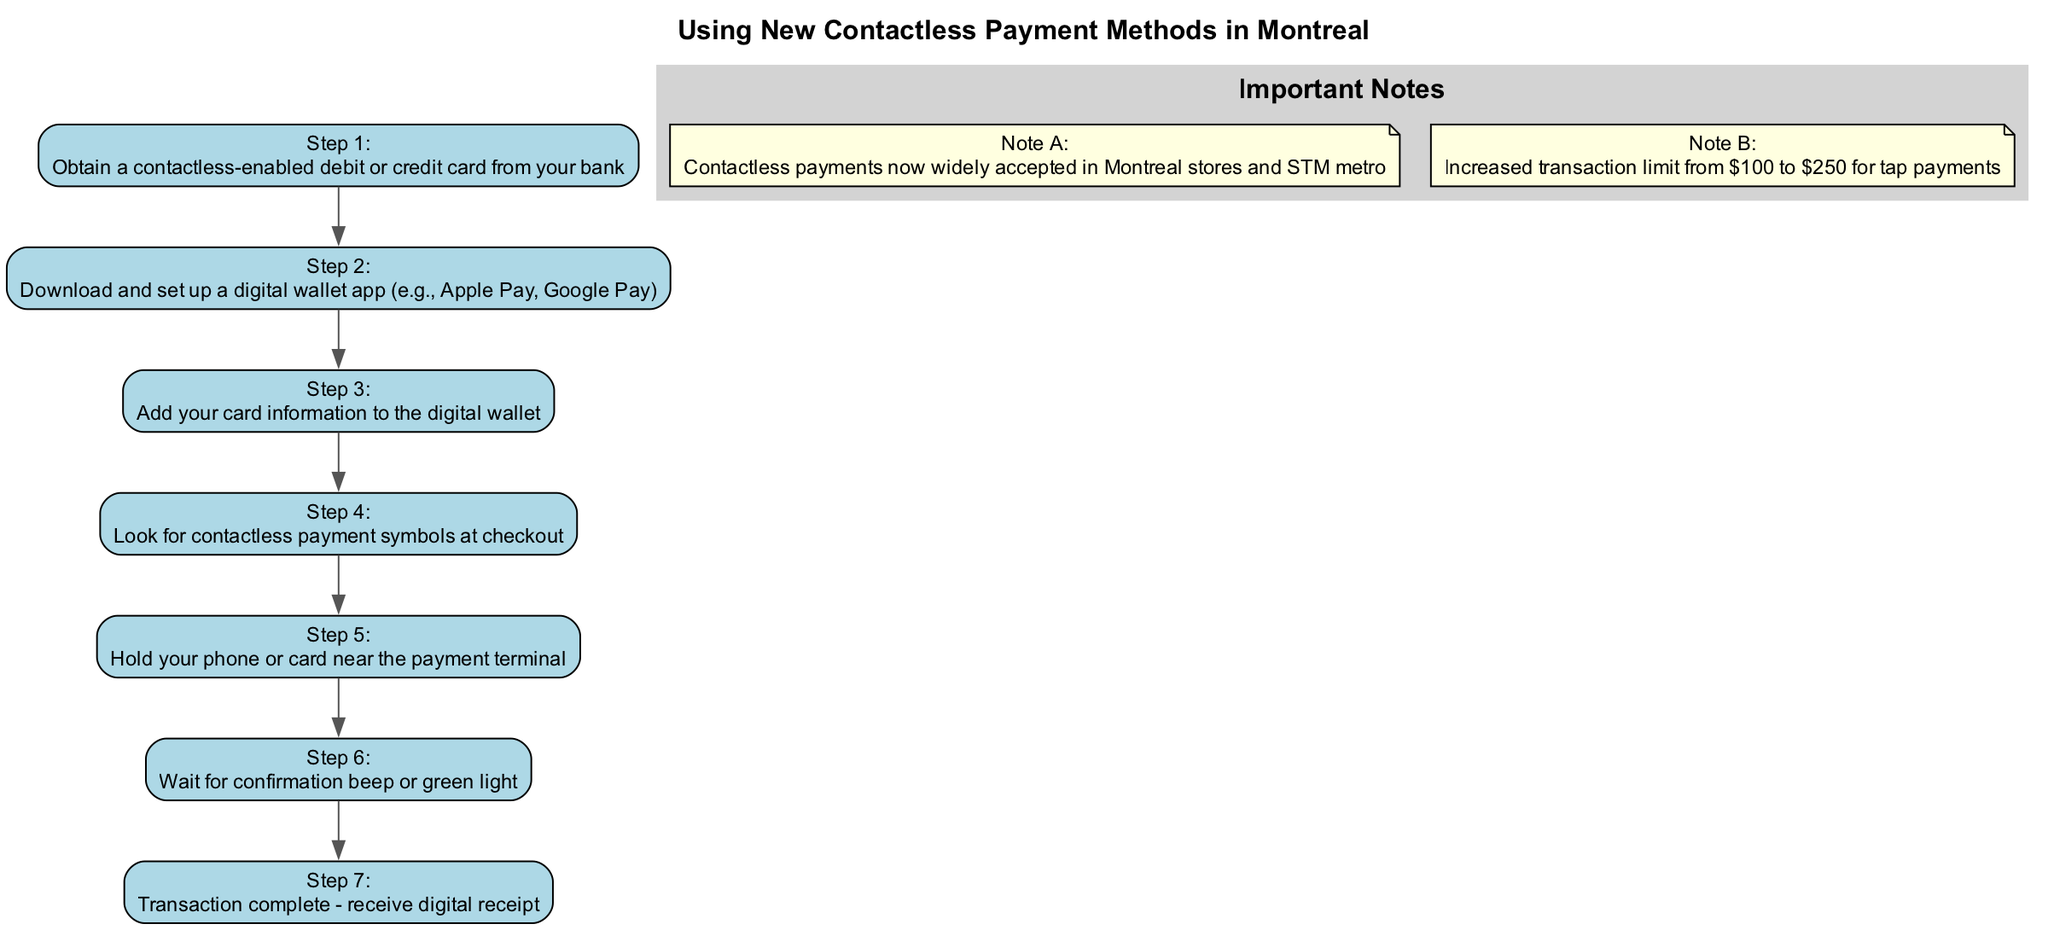What is the first step in the diagram? The first step in the diagram is stated clearly as "Obtain a contactless-enabled debit or credit card from your bank." This can be found at the beginning of the flow.
Answer: Obtain a contactless-enabled debit or credit card from your bank How many steps are there in total? The diagram outlines a sequence of steps labeled from 1 to 7, which totals to seven distinct steps in the process.
Answer: 7 What is the action in step 5? Step 5 indicates the action to "Hold your phone or card near the payment terminal," which describes the physical action required at this point in the process.
Answer: Hold your phone or card near the payment terminal Which step comes after adding card information? According to the progression of the steps, after adding card information in step 3, the next action is step 4, which involves looking for contactless payment symbols at checkout.
Answer: Look for contactless payment symbols at checkout What important note mentions the transaction limit? Note B addresses the increased transaction limit for tap payments, specifying it has risen from $100 to $250. This note provides vital information related to financial transactions.
Answer: Increased transaction limit from $100 to $250 for tap payments What is the last step listed in the diagram? The final step, which is step 7, states "Transaction complete - receive digital receipt." This indicates the outcome of completing the payment process.
Answer: Transaction complete - receive digital receipt 